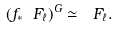Convert formula to latex. <formula><loc_0><loc_0><loc_500><loc_500>( f _ { * } \ F _ { \ell } ) ^ { G } \simeq \ F _ { \ell } .</formula> 